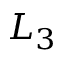Convert formula to latex. <formula><loc_0><loc_0><loc_500><loc_500>L _ { 3 }</formula> 